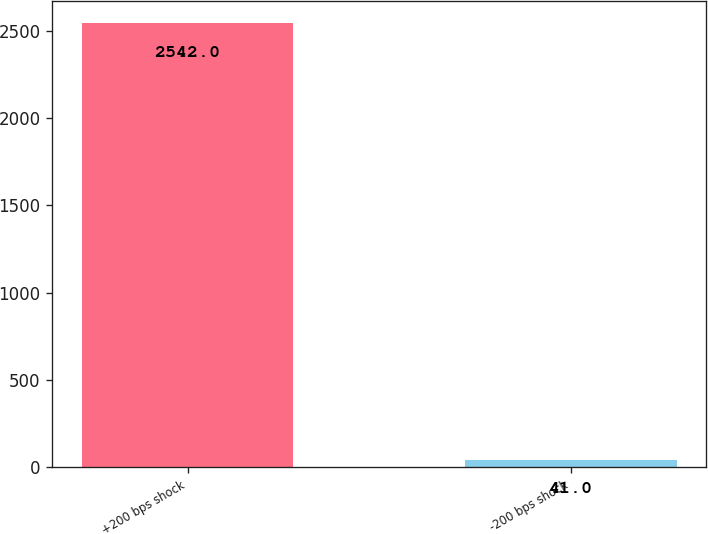Convert chart to OTSL. <chart><loc_0><loc_0><loc_500><loc_500><bar_chart><fcel>+200 bps shock<fcel>-200 bps shock<nl><fcel>2542<fcel>41<nl></chart> 